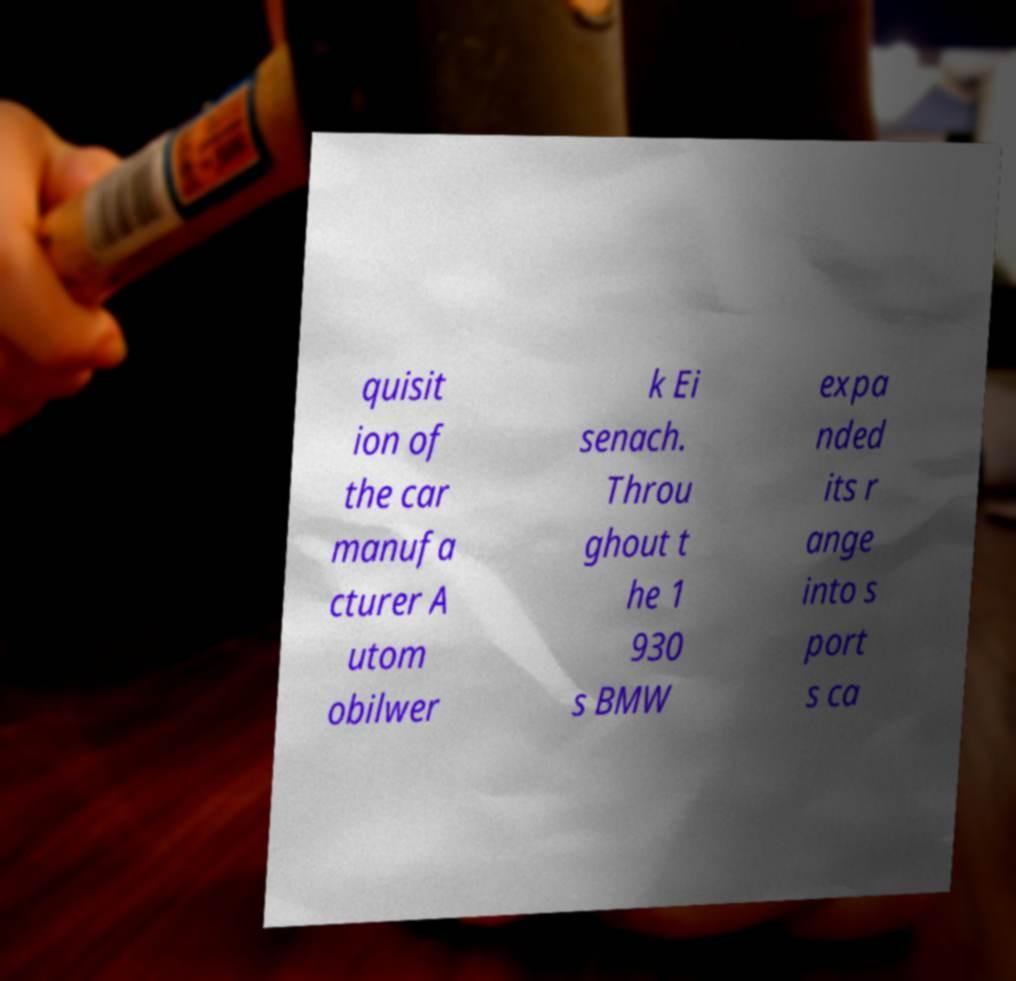There's text embedded in this image that I need extracted. Can you transcribe it verbatim? quisit ion of the car manufa cturer A utom obilwer k Ei senach. Throu ghout t he 1 930 s BMW expa nded its r ange into s port s ca 